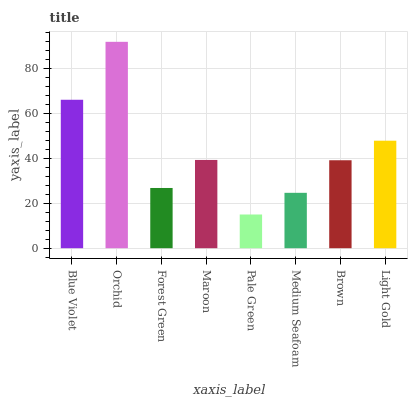Is Pale Green the minimum?
Answer yes or no. Yes. Is Orchid the maximum?
Answer yes or no. Yes. Is Forest Green the minimum?
Answer yes or no. No. Is Forest Green the maximum?
Answer yes or no. No. Is Orchid greater than Forest Green?
Answer yes or no. Yes. Is Forest Green less than Orchid?
Answer yes or no. Yes. Is Forest Green greater than Orchid?
Answer yes or no. No. Is Orchid less than Forest Green?
Answer yes or no. No. Is Maroon the high median?
Answer yes or no. Yes. Is Brown the low median?
Answer yes or no. Yes. Is Medium Seafoam the high median?
Answer yes or no. No. Is Maroon the low median?
Answer yes or no. No. 